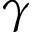Convert formula to latex. <formula><loc_0><loc_0><loc_500><loc_500>\gamma</formula> 